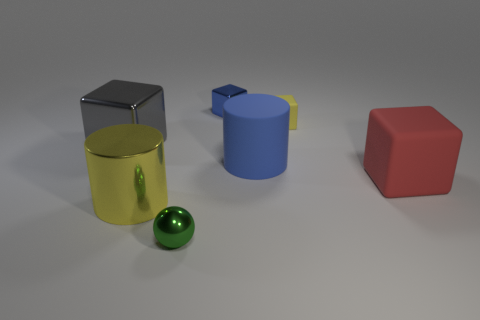Subtract all tiny yellow blocks. How many blocks are left? 3 Add 1 large red rubber objects. How many objects exist? 8 Subtract all cubes. How many objects are left? 3 Subtract 1 balls. How many balls are left? 0 Subtract all yellow cubes. How many cubes are left? 3 Add 6 large brown spheres. How many large brown spheres exist? 6 Subtract 0 purple cubes. How many objects are left? 7 Subtract all blue blocks. Subtract all red cylinders. How many blocks are left? 3 Subtract all gray cubes. How many purple cylinders are left? 0 Subtract all tiny brown rubber cylinders. Subtract all large blue cylinders. How many objects are left? 6 